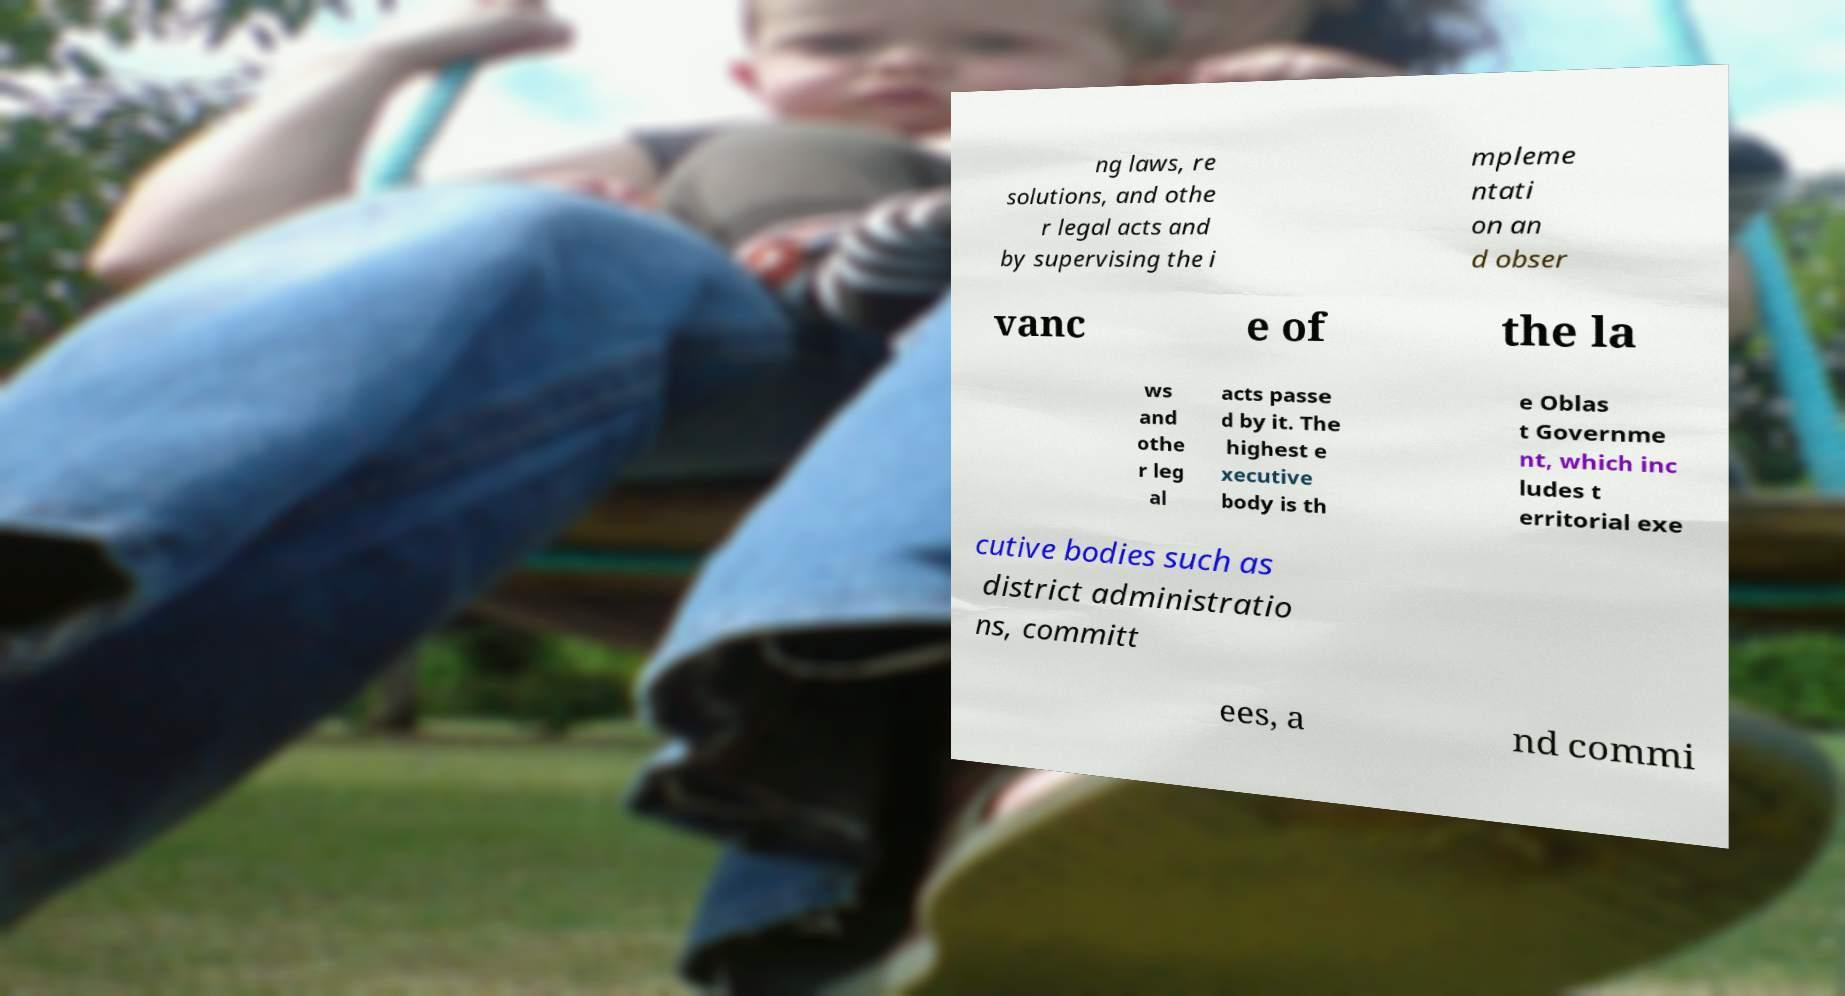Could you assist in decoding the text presented in this image and type it out clearly? ng laws, re solutions, and othe r legal acts and by supervising the i mpleme ntati on an d obser vanc e of the la ws and othe r leg al acts passe d by it. The highest e xecutive body is th e Oblas t Governme nt, which inc ludes t erritorial exe cutive bodies such as district administratio ns, committ ees, a nd commi 